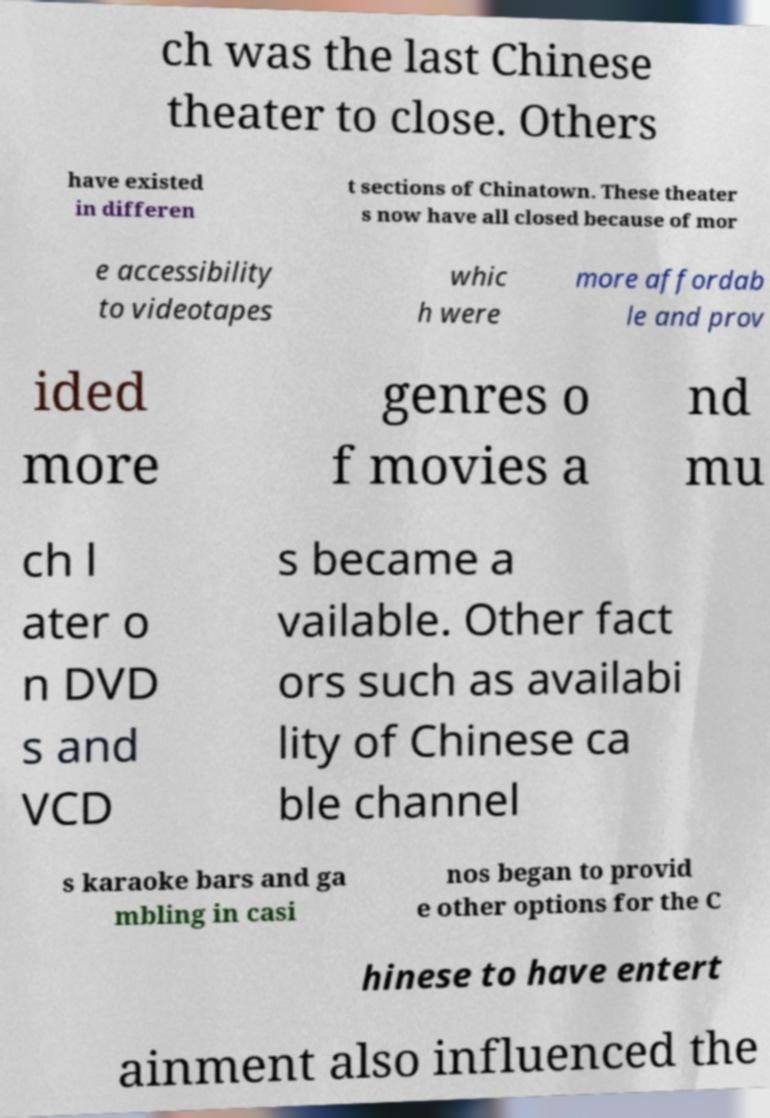I need the written content from this picture converted into text. Can you do that? ch was the last Chinese theater to close. Others have existed in differen t sections of Chinatown. These theater s now have all closed because of mor e accessibility to videotapes whic h were more affordab le and prov ided more genres o f movies a nd mu ch l ater o n DVD s and VCD s became a vailable. Other fact ors such as availabi lity of Chinese ca ble channel s karaoke bars and ga mbling in casi nos began to provid e other options for the C hinese to have entert ainment also influenced the 